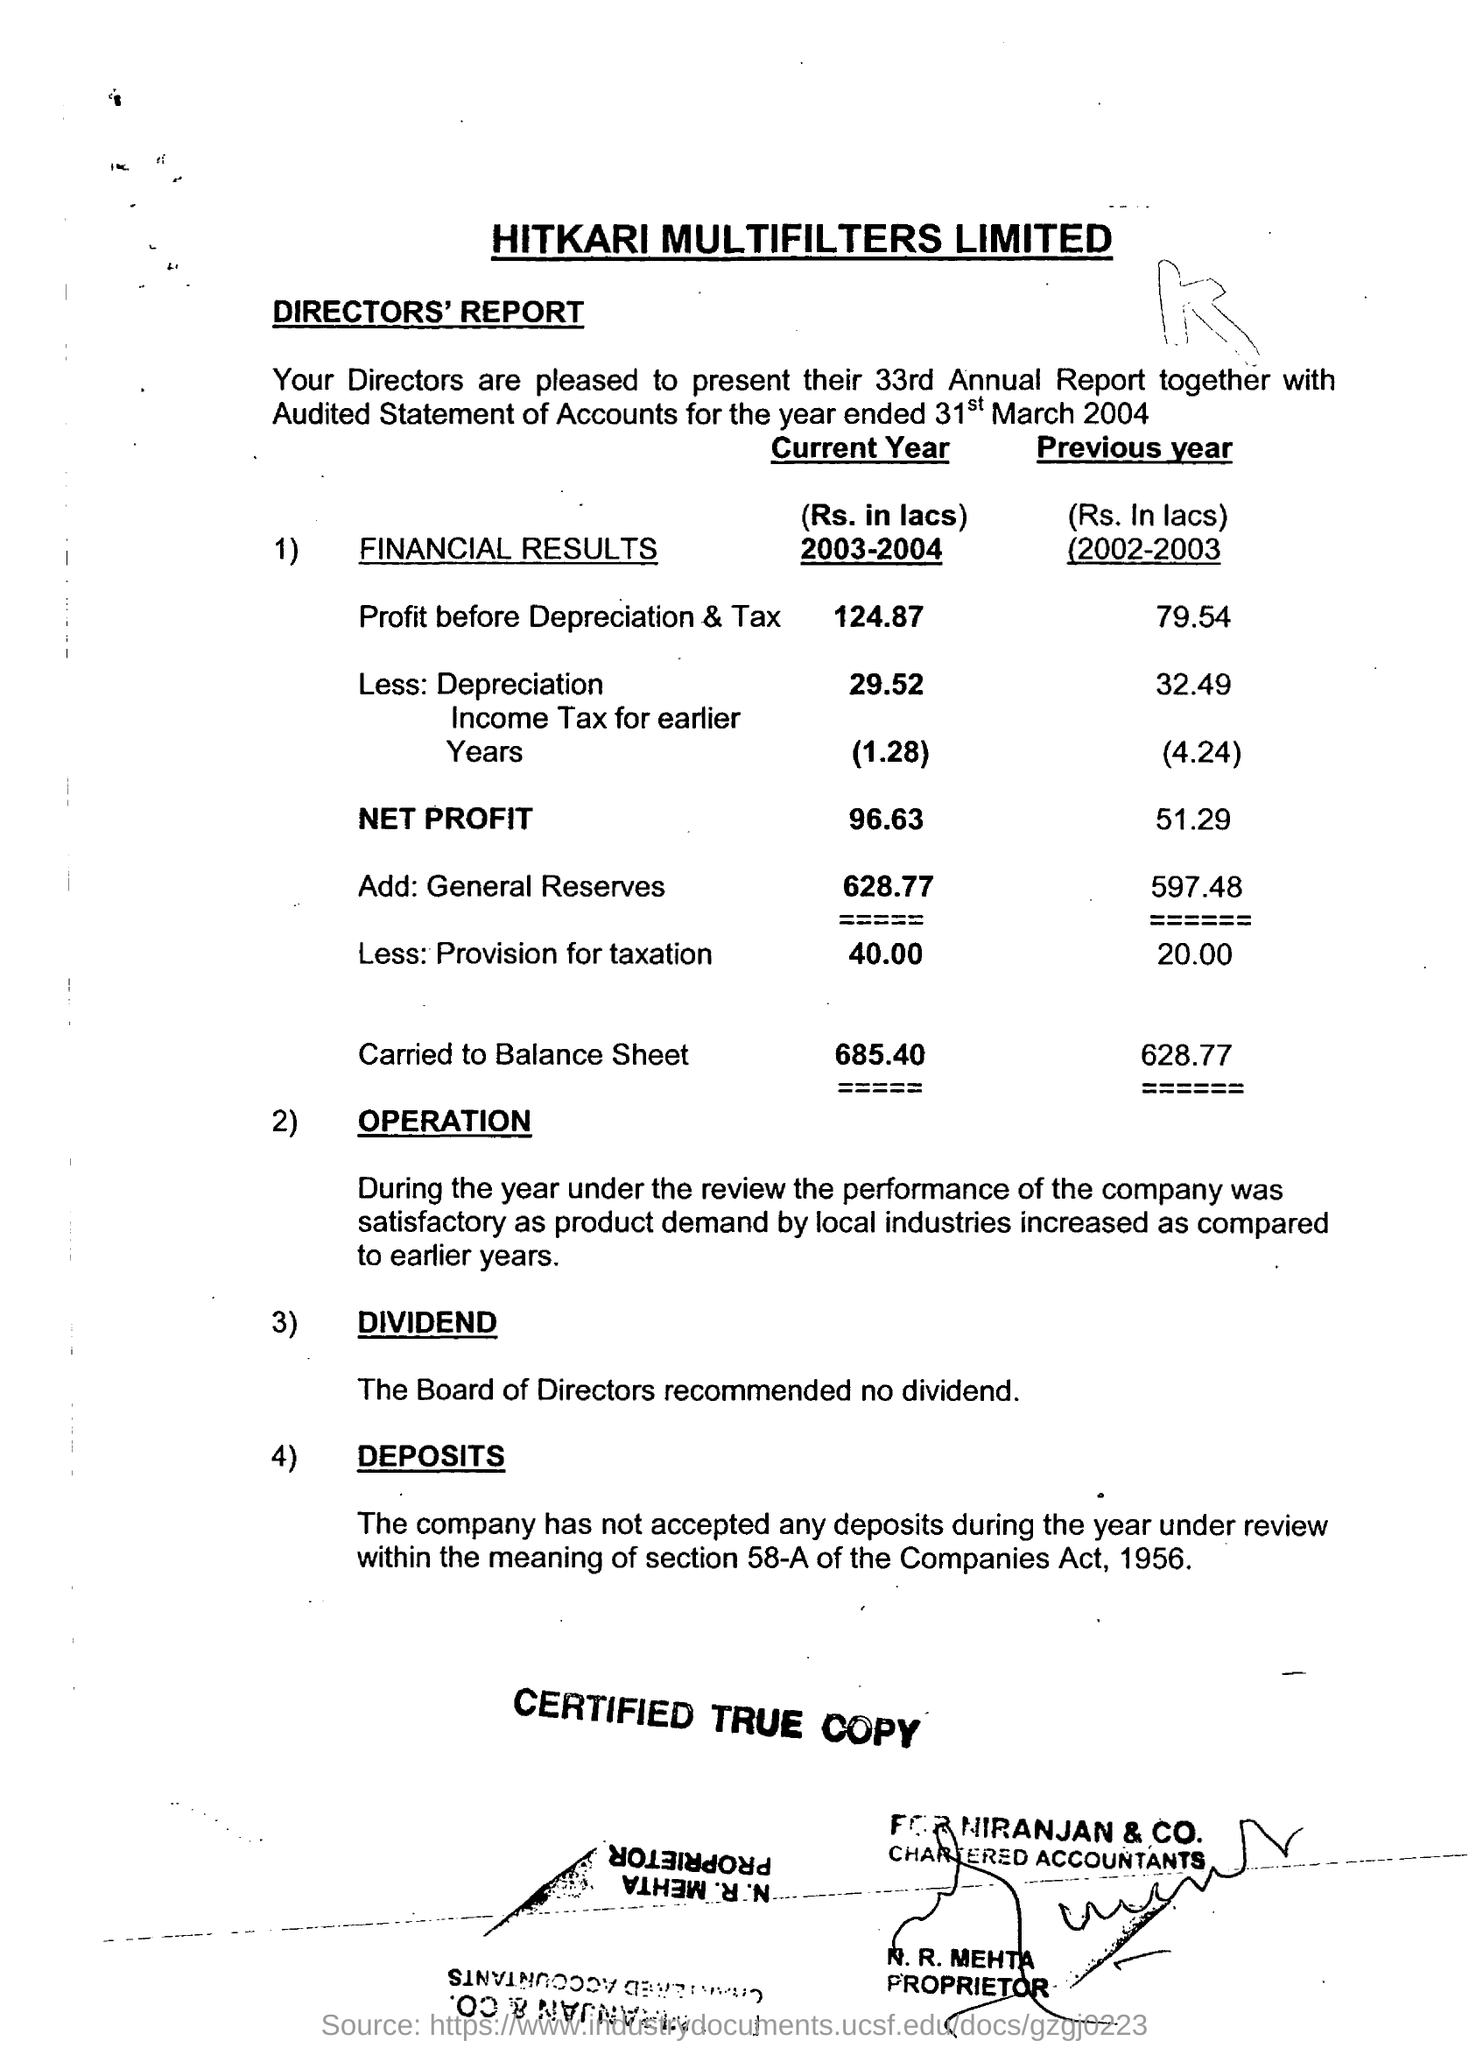Highlight a few significant elements in this photo. The net profit of the current year is 96.63. The title of the document is: HITKARI MULTIFILTERS LIMITED. The carried amount of the balance sheet in the 2003-2004 year was 685.40. 